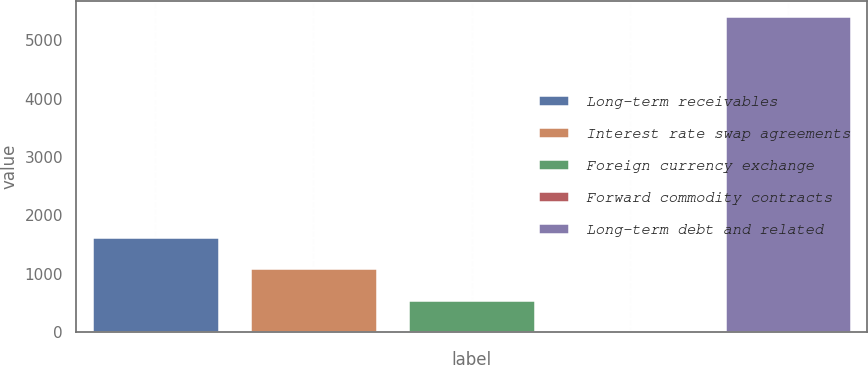Convert chart. <chart><loc_0><loc_0><loc_500><loc_500><bar_chart><fcel>Long-term receivables<fcel>Interest rate swap agreements<fcel>Foreign currency exchange<fcel>Forward commodity contracts<fcel>Long-term debt and related<nl><fcel>1630.3<fcel>1090.2<fcel>550.1<fcel>10<fcel>5411<nl></chart> 